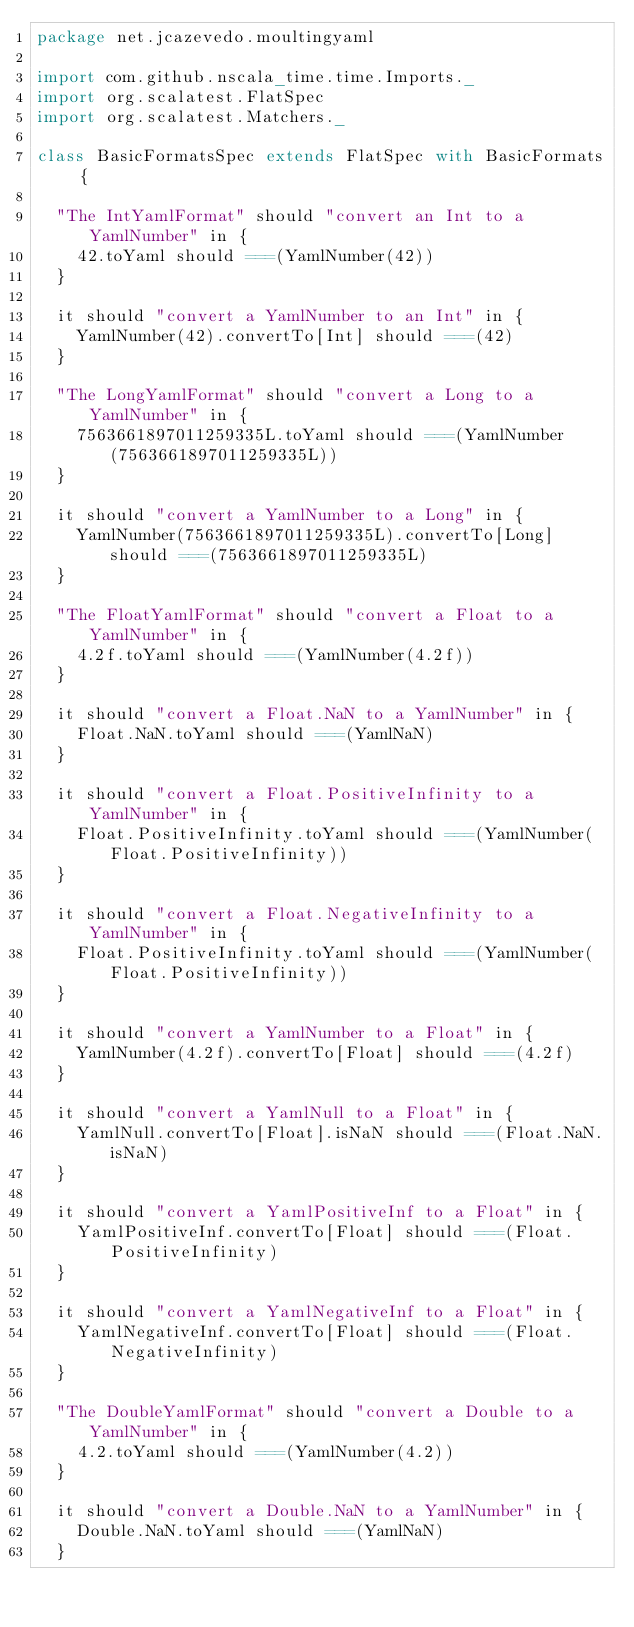<code> <loc_0><loc_0><loc_500><loc_500><_Scala_>package net.jcazevedo.moultingyaml

import com.github.nscala_time.time.Imports._
import org.scalatest.FlatSpec
import org.scalatest.Matchers._

class BasicFormatsSpec extends FlatSpec with BasicFormats {

  "The IntYamlFormat" should "convert an Int to a YamlNumber" in {
    42.toYaml should ===(YamlNumber(42))
  }

  it should "convert a YamlNumber to an Int" in {
    YamlNumber(42).convertTo[Int] should ===(42)
  }

  "The LongYamlFormat" should "convert a Long to a YamlNumber" in {
    7563661897011259335L.toYaml should ===(YamlNumber(7563661897011259335L))
  }

  it should "convert a YamlNumber to a Long" in {
    YamlNumber(7563661897011259335L).convertTo[Long] should ===(7563661897011259335L)
  }

  "The FloatYamlFormat" should "convert a Float to a YamlNumber" in {
    4.2f.toYaml should ===(YamlNumber(4.2f))
  }

  it should "convert a Float.NaN to a YamlNumber" in {
    Float.NaN.toYaml should ===(YamlNaN)
  }

  it should "convert a Float.PositiveInfinity to a YamlNumber" in {
    Float.PositiveInfinity.toYaml should ===(YamlNumber(Float.PositiveInfinity))
  }

  it should "convert a Float.NegativeInfinity to a YamlNumber" in {
    Float.PositiveInfinity.toYaml should ===(YamlNumber(Float.PositiveInfinity))
  }

  it should "convert a YamlNumber to a Float" in {
    YamlNumber(4.2f).convertTo[Float] should ===(4.2f)
  }

  it should "convert a YamlNull to a Float" in {
    YamlNull.convertTo[Float].isNaN should ===(Float.NaN.isNaN)
  }

  it should "convert a YamlPositiveInf to a Float" in {
    YamlPositiveInf.convertTo[Float] should ===(Float.PositiveInfinity)
  }

  it should "convert a YamlNegativeInf to a Float" in {
    YamlNegativeInf.convertTo[Float] should ===(Float.NegativeInfinity)
  }

  "The DoubleYamlFormat" should "convert a Double to a YamlNumber" in {
    4.2.toYaml should ===(YamlNumber(4.2))
  }

  it should "convert a Double.NaN to a YamlNumber" in {
    Double.NaN.toYaml should ===(YamlNaN)
  }
</code> 